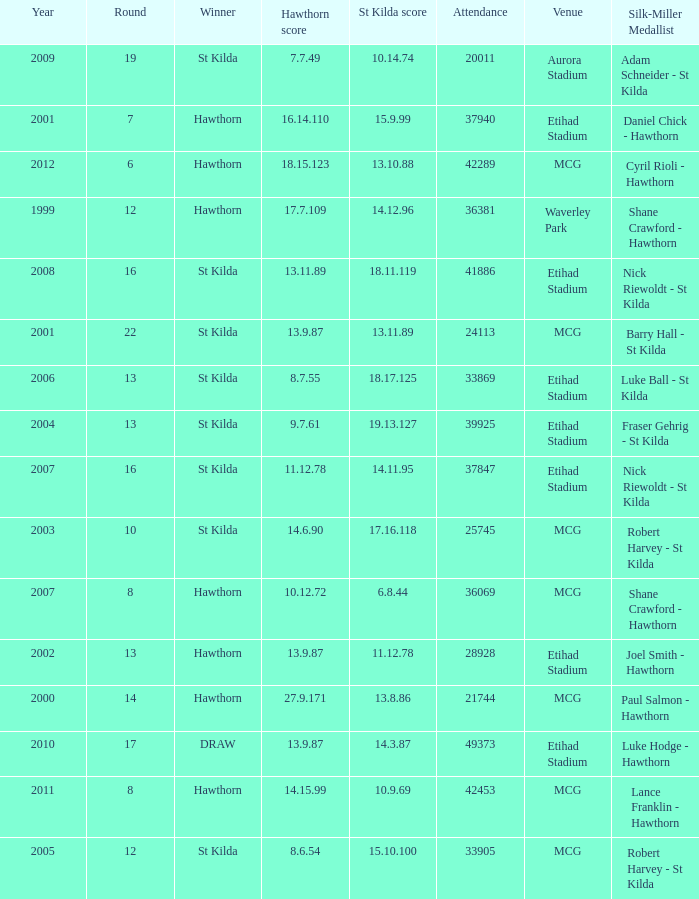What the listed in round when the hawthorn score is 17.7.109? 12.0. 